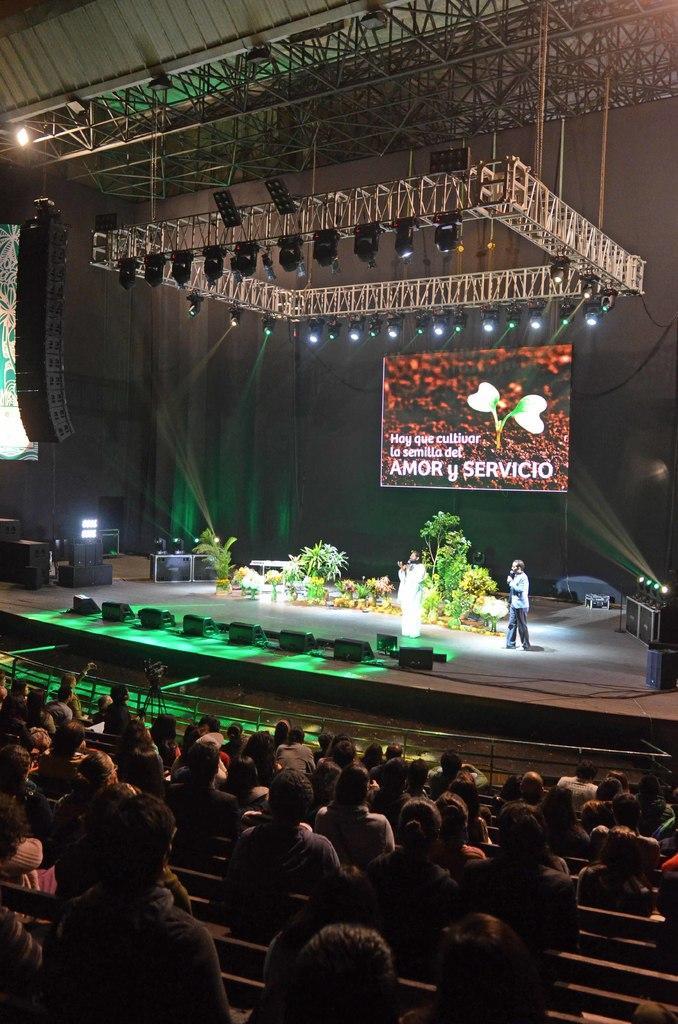How would you summarize this image in a sentence or two? In this image we can see two persons on a stage. On the stage we can see few plants and we can see lights and banners. In the foreground we can see group of persons in an auditorium. 